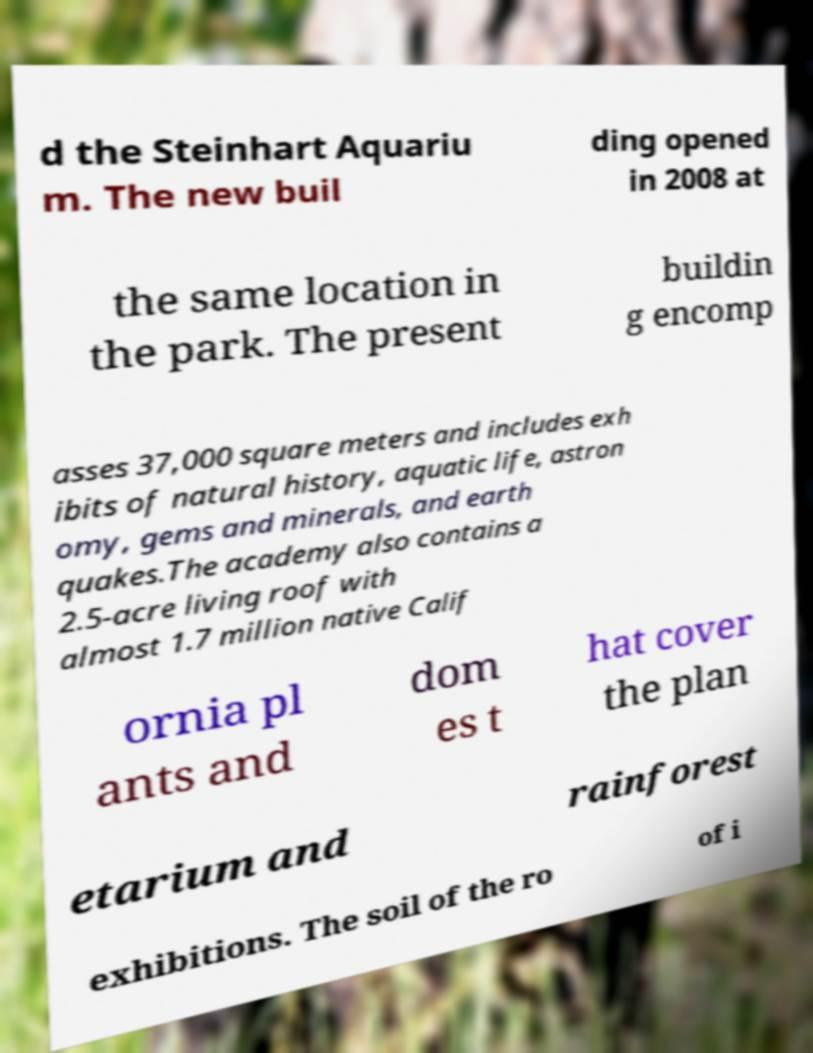There's text embedded in this image that I need extracted. Can you transcribe it verbatim? d the Steinhart Aquariu m. The new buil ding opened in 2008 at the same location in the park. The present buildin g encomp asses 37,000 square meters and includes exh ibits of natural history, aquatic life, astron omy, gems and minerals, and earth quakes.The academy also contains a 2.5-acre living roof with almost 1.7 million native Calif ornia pl ants and dom es t hat cover the plan etarium and rainforest exhibitions. The soil of the ro of i 